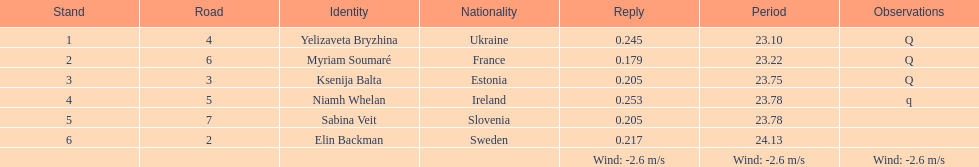Identify the sportswoman who finished first in heat 1 of the women's 200 meters. Yelizaveta Bryzhina. 